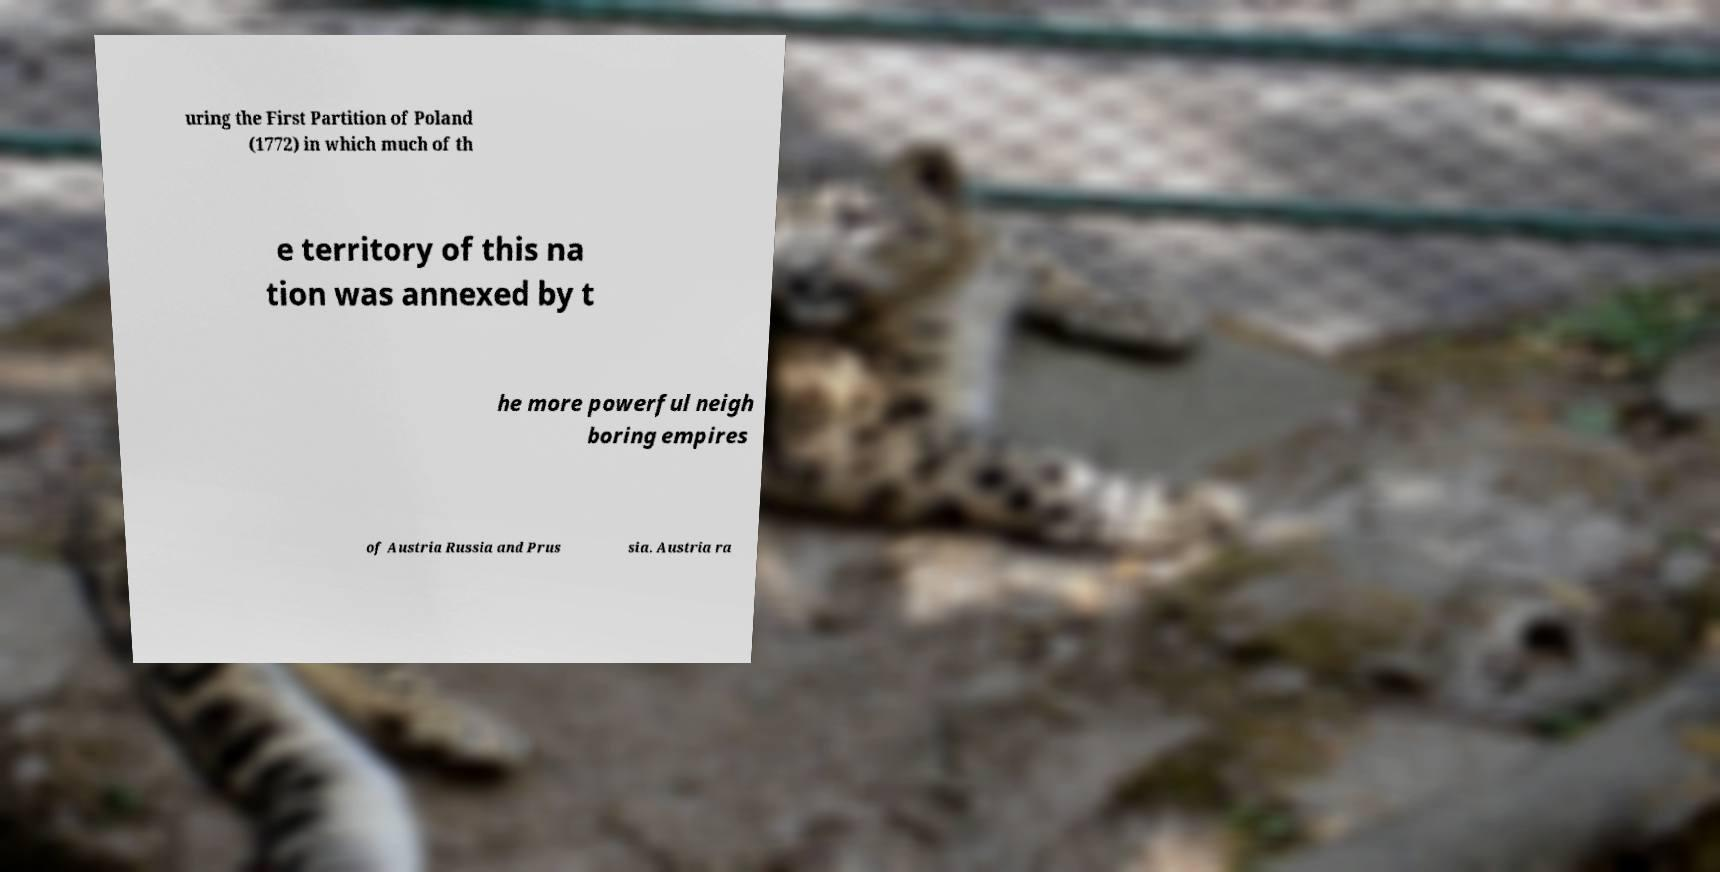Could you assist in decoding the text presented in this image and type it out clearly? uring the First Partition of Poland (1772) in which much of th e territory of this na tion was annexed by t he more powerful neigh boring empires of Austria Russia and Prus sia. Austria ra 